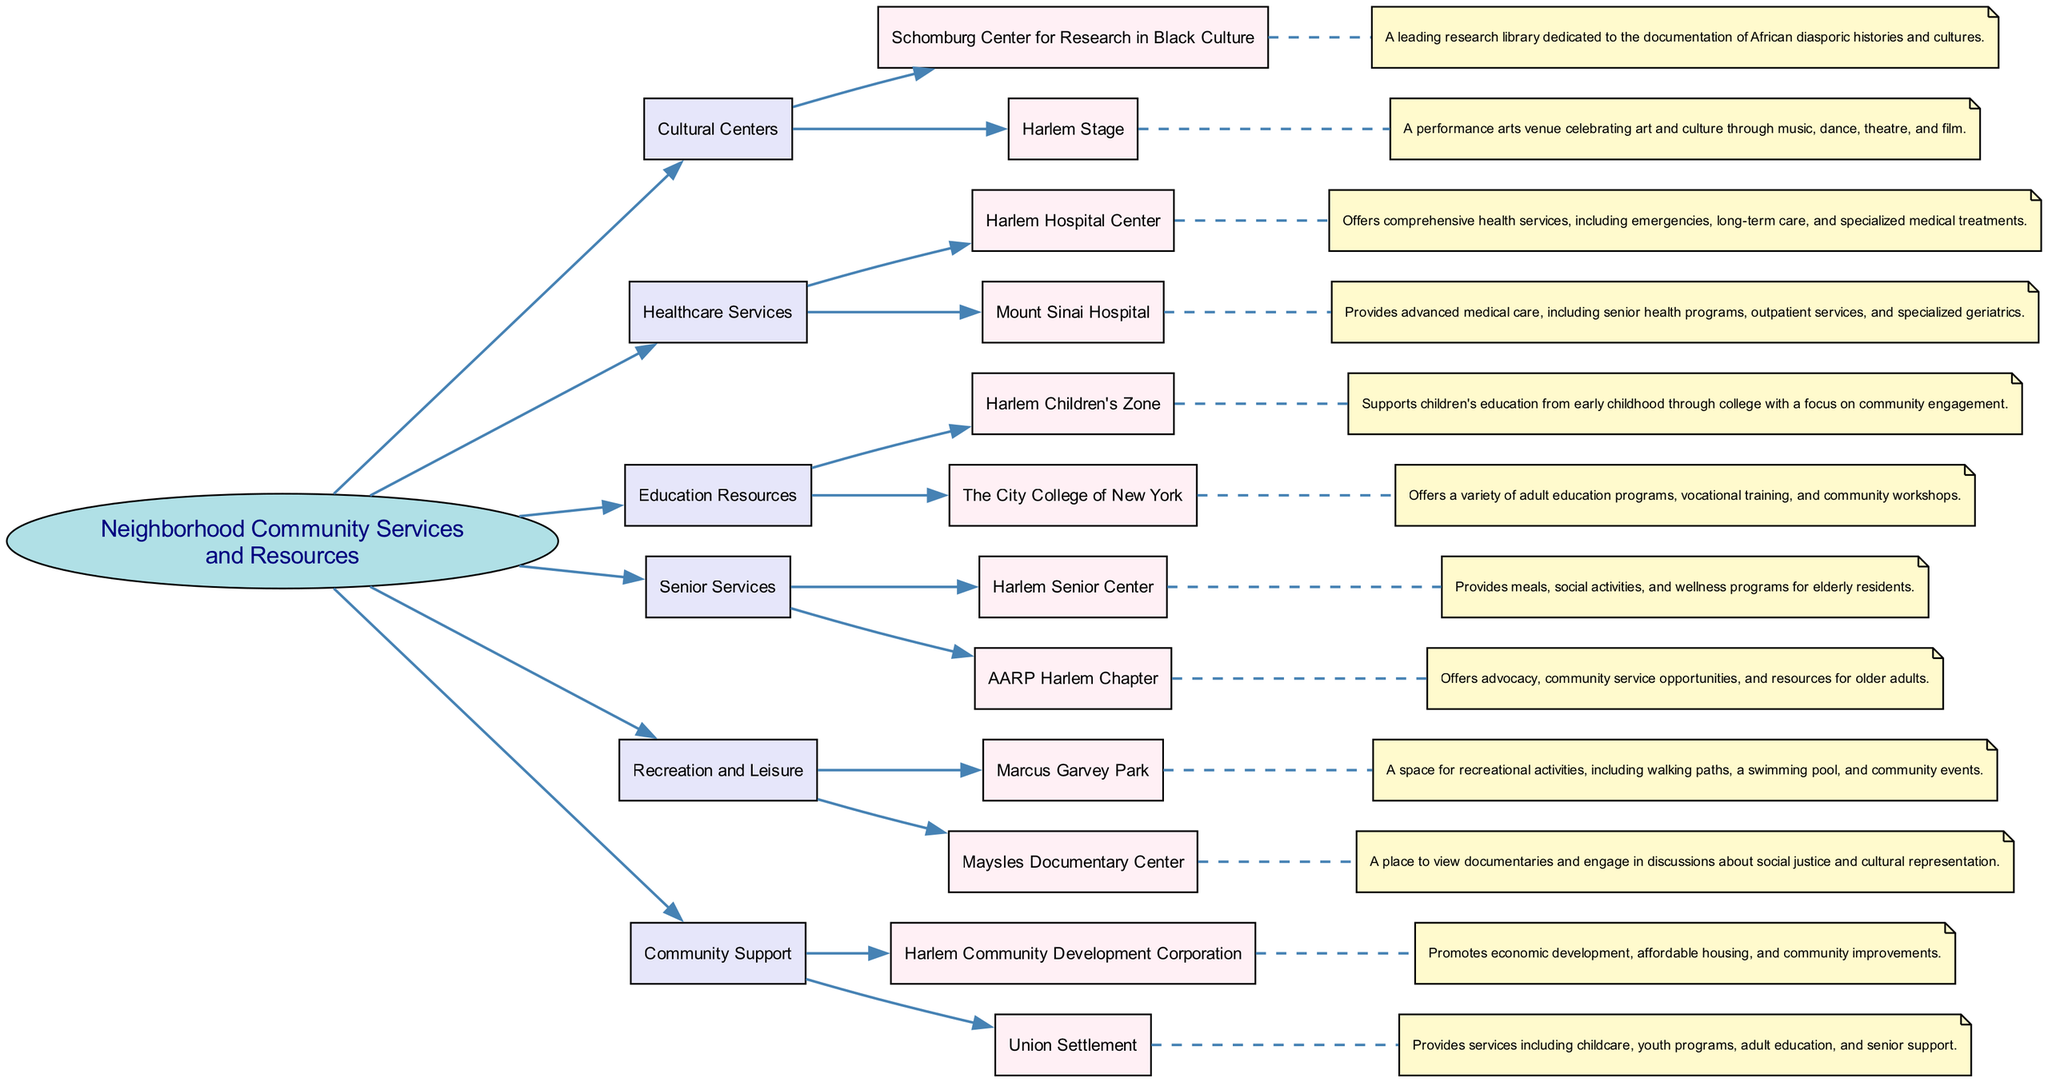What are two examples of cultural centers listed in the diagram? The diagram indicates that the cultural centers are "Schomburg Center for Research in Black Culture" and "Harlem Stage." By examining the node under "Cultural Centers," I can find these two examples listed.
Answer: Schomburg Center for Research in Black Culture, Harlem Stage How many healthcare services are provided in the neighborhood? In the diagram, there are two nodes under the "Healthcare Services" category: "Harlem Hospital Center" and "Mount Sinai Hospital." This means there are two specific healthcare services provided.
Answer: 2 Which organization focuses on children's education? The "Harlem Children's Zone" is the node listed under "Education Resources," specifically focusing on supporting children's education. By checking the "Education Resources" section of the diagram, this organization is identified as the one dedicated to children's education.
Answer: Harlem Children's Zone What is a primary service offered by the Harlem Senior Center? According to the diagram, the Harlem Senior Center provides "meals, social activities, and wellness programs." Each of these aspects is highlighted as a key offering of the center under the "Senior Services" category.
Answer: Meals, social activities, and wellness programs Which community support organization promotes economic development? The "Harlem Community Development Corporation" is indicated in the diagram as the organization that promotes economic development, among other community improvements. This can be found within the "Community Support" category.
Answer: Harlem Community Development Corporation What type of activities can you find in Marcus Garvey Park? The diagram specifies that "recreational activities, including walking paths, a swimming pool, and community events" are available in Marcus Garvey Park. This information can be directly sourced from the "Recreation and Leisure" section of the diagram.
Answer: Recreational activities, including walking paths, a swimming pool, and community events Which healthcare service includes senior health programs? "Mount Sinai Hospital" is mentioned in the healthcare services category and is noted for providing advanced medical care, including senior health programs. Checking the "Healthcare Services" section leads to this specific information.
Answer: Mount Sinai Hospital Name one resource that offers adult education programs. The diagram states that "The City College of New York" provides various adult education programs. This information is found under the "Education Resources" section where adult education initiatives are highlighted.
Answer: The City College of New York 